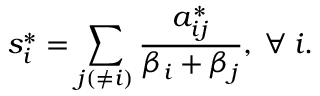<formula> <loc_0><loc_0><loc_500><loc_500>s _ { i } ^ { * } = \sum _ { j ( \neq i ) } \frac { a _ { i j } ^ { * } } { \beta _ { i } + \beta _ { j } } , \, \forall \, i .</formula> 